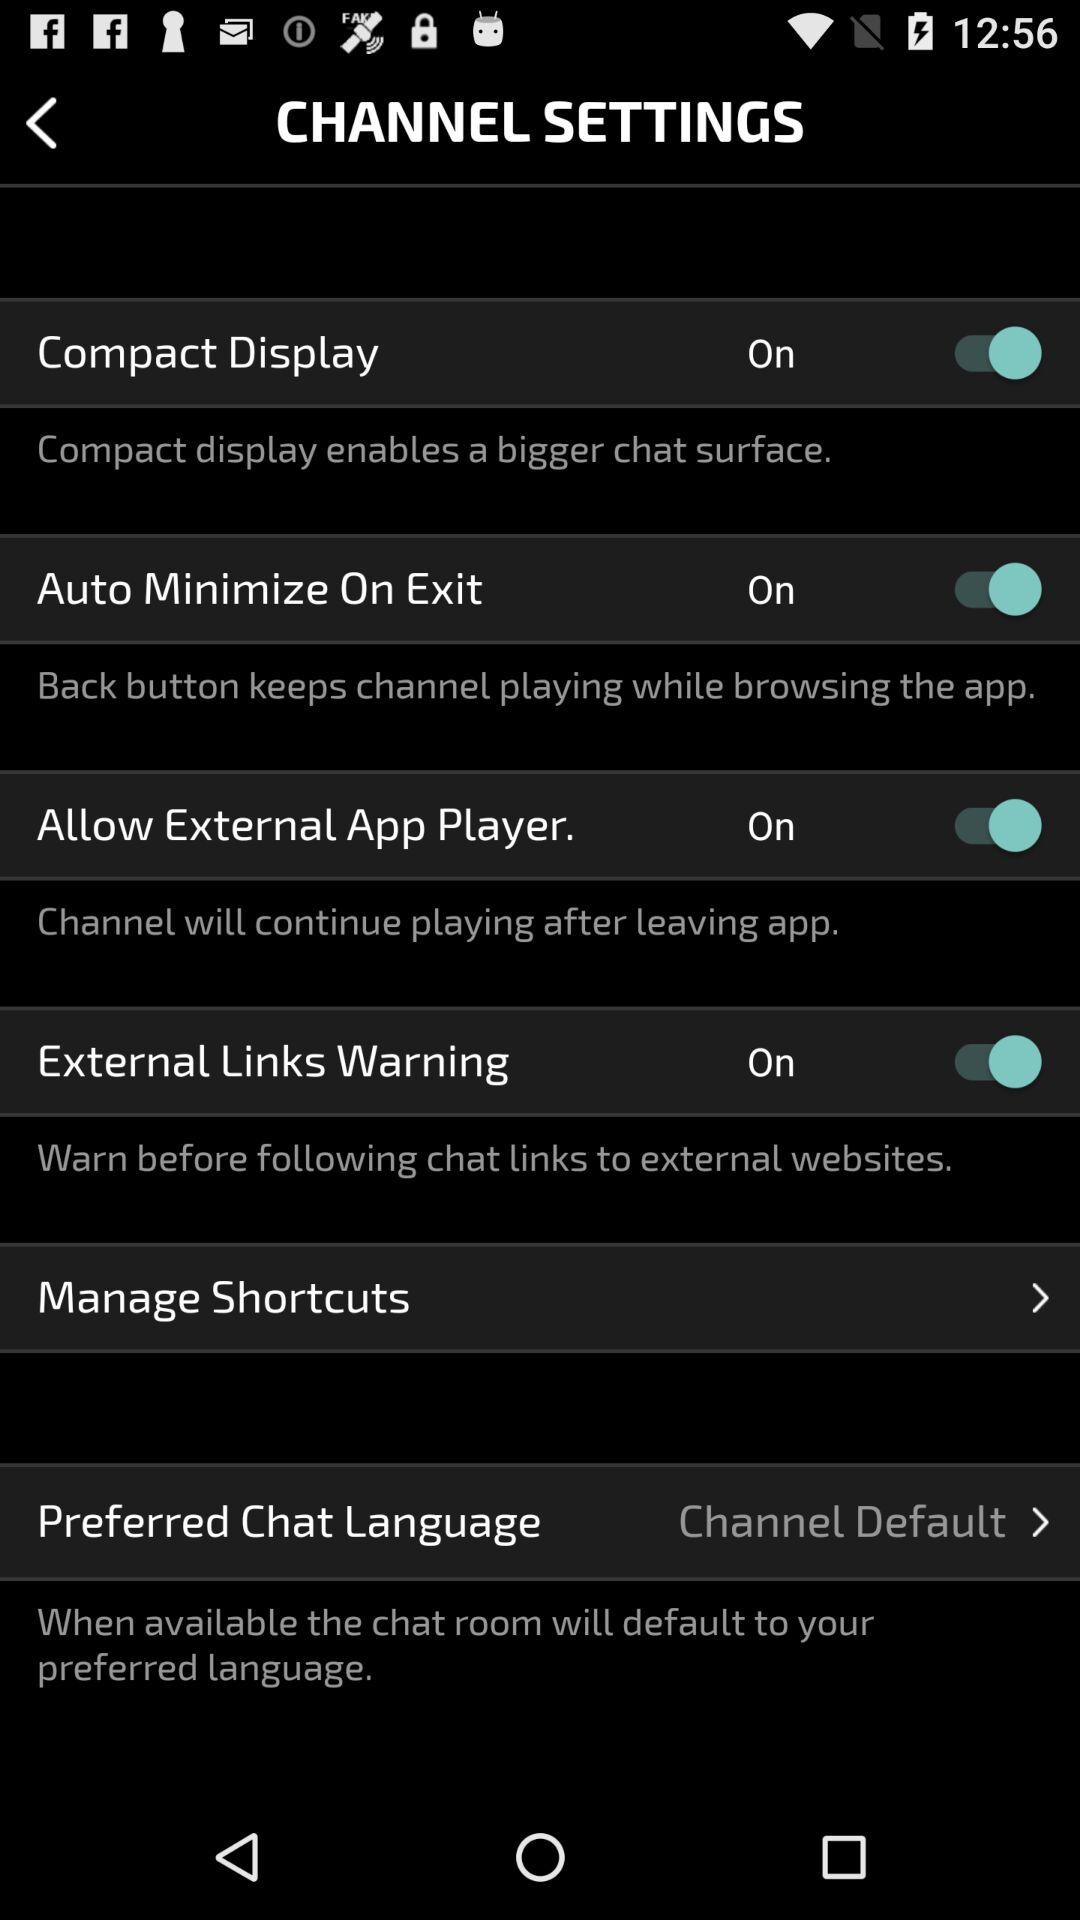What is the current status of "Auto Minimize On Exit"? The current status is "on". 